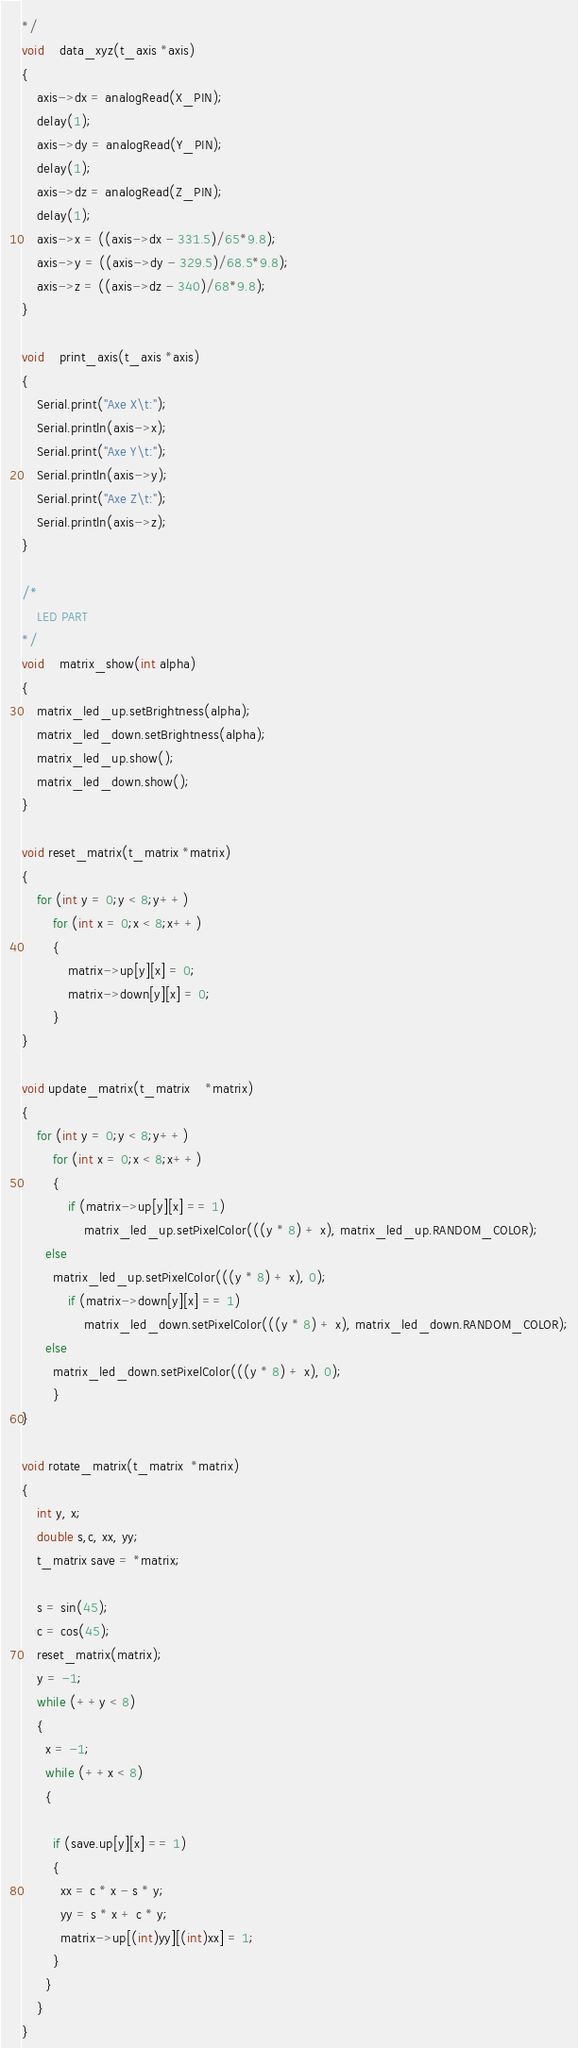Convert code to text. <code><loc_0><loc_0><loc_500><loc_500><_C++_>*/
void	data_xyz(t_axis *axis)
{
	axis->dx = analogRead(X_PIN);
	delay(1);
	axis->dy = analogRead(Y_PIN);
	delay(1); 
	axis->dz = analogRead(Z_PIN);
	delay(1);
	axis->x = ((axis->dx - 331.5)/65*9.8);
	axis->y = ((axis->dy - 329.5)/68.5*9.8);
	axis->z = ((axis->dz - 340)/68*9.8);
}

void	print_axis(t_axis *axis)
{
	Serial.print("Axe X\t:");
	Serial.println(axis->x);
	Serial.print("Axe Y\t:");
	Serial.println(axis->y);
	Serial.print("Axe Z\t:");
	Serial.println(axis->z);
}

/*
	LED PART
*/
void	matrix_show(int alpha)
{
	matrix_led_up.setBrightness(alpha);
	matrix_led_down.setBrightness(alpha);
	matrix_led_up.show();
	matrix_led_down.show();
}

void reset_matrix(t_matrix *matrix)
{
	for (int y = 0;y < 8;y++)
		for (int x = 0;x < 8;x++)
		{
			matrix->up[y][x] = 0;
			matrix->down[y][x] = 0;
		}
}

void update_matrix(t_matrix	*matrix)
{
	for (int y = 0;y < 8;y++)
		for (int x = 0;x < 8;x++)
		{
			if (matrix->up[y][x] == 1)
				matrix_led_up.setPixelColor(((y * 8) + x), matrix_led_up.RANDOM_COLOR);
      else
        matrix_led_up.setPixelColor(((y * 8) + x), 0);
			if (matrix->down[y][x] == 1)
				matrix_led_down.setPixelColor(((y * 8) + x), matrix_led_down.RANDOM_COLOR);
      else
        matrix_led_down.setPixelColor(((y * 8) + x), 0);
		}
}

void rotate_matrix(t_matrix  *matrix)
{
    int y, x;
    double s,c, xx, yy;
    t_matrix save = *matrix;

    s = sin(45);
    c = cos(45);
    reset_matrix(matrix);
    y = -1;
    while (++y < 8)
    {
      x = -1;
      while (++x < 8)
      {
        
        if (save.up[y][x] == 1)
        {
          xx = c * x - s * y;
          yy = s * x + c * y;
          matrix->up[(int)yy][(int)xx] = 1;
        }
      }
    }
}
</code> 